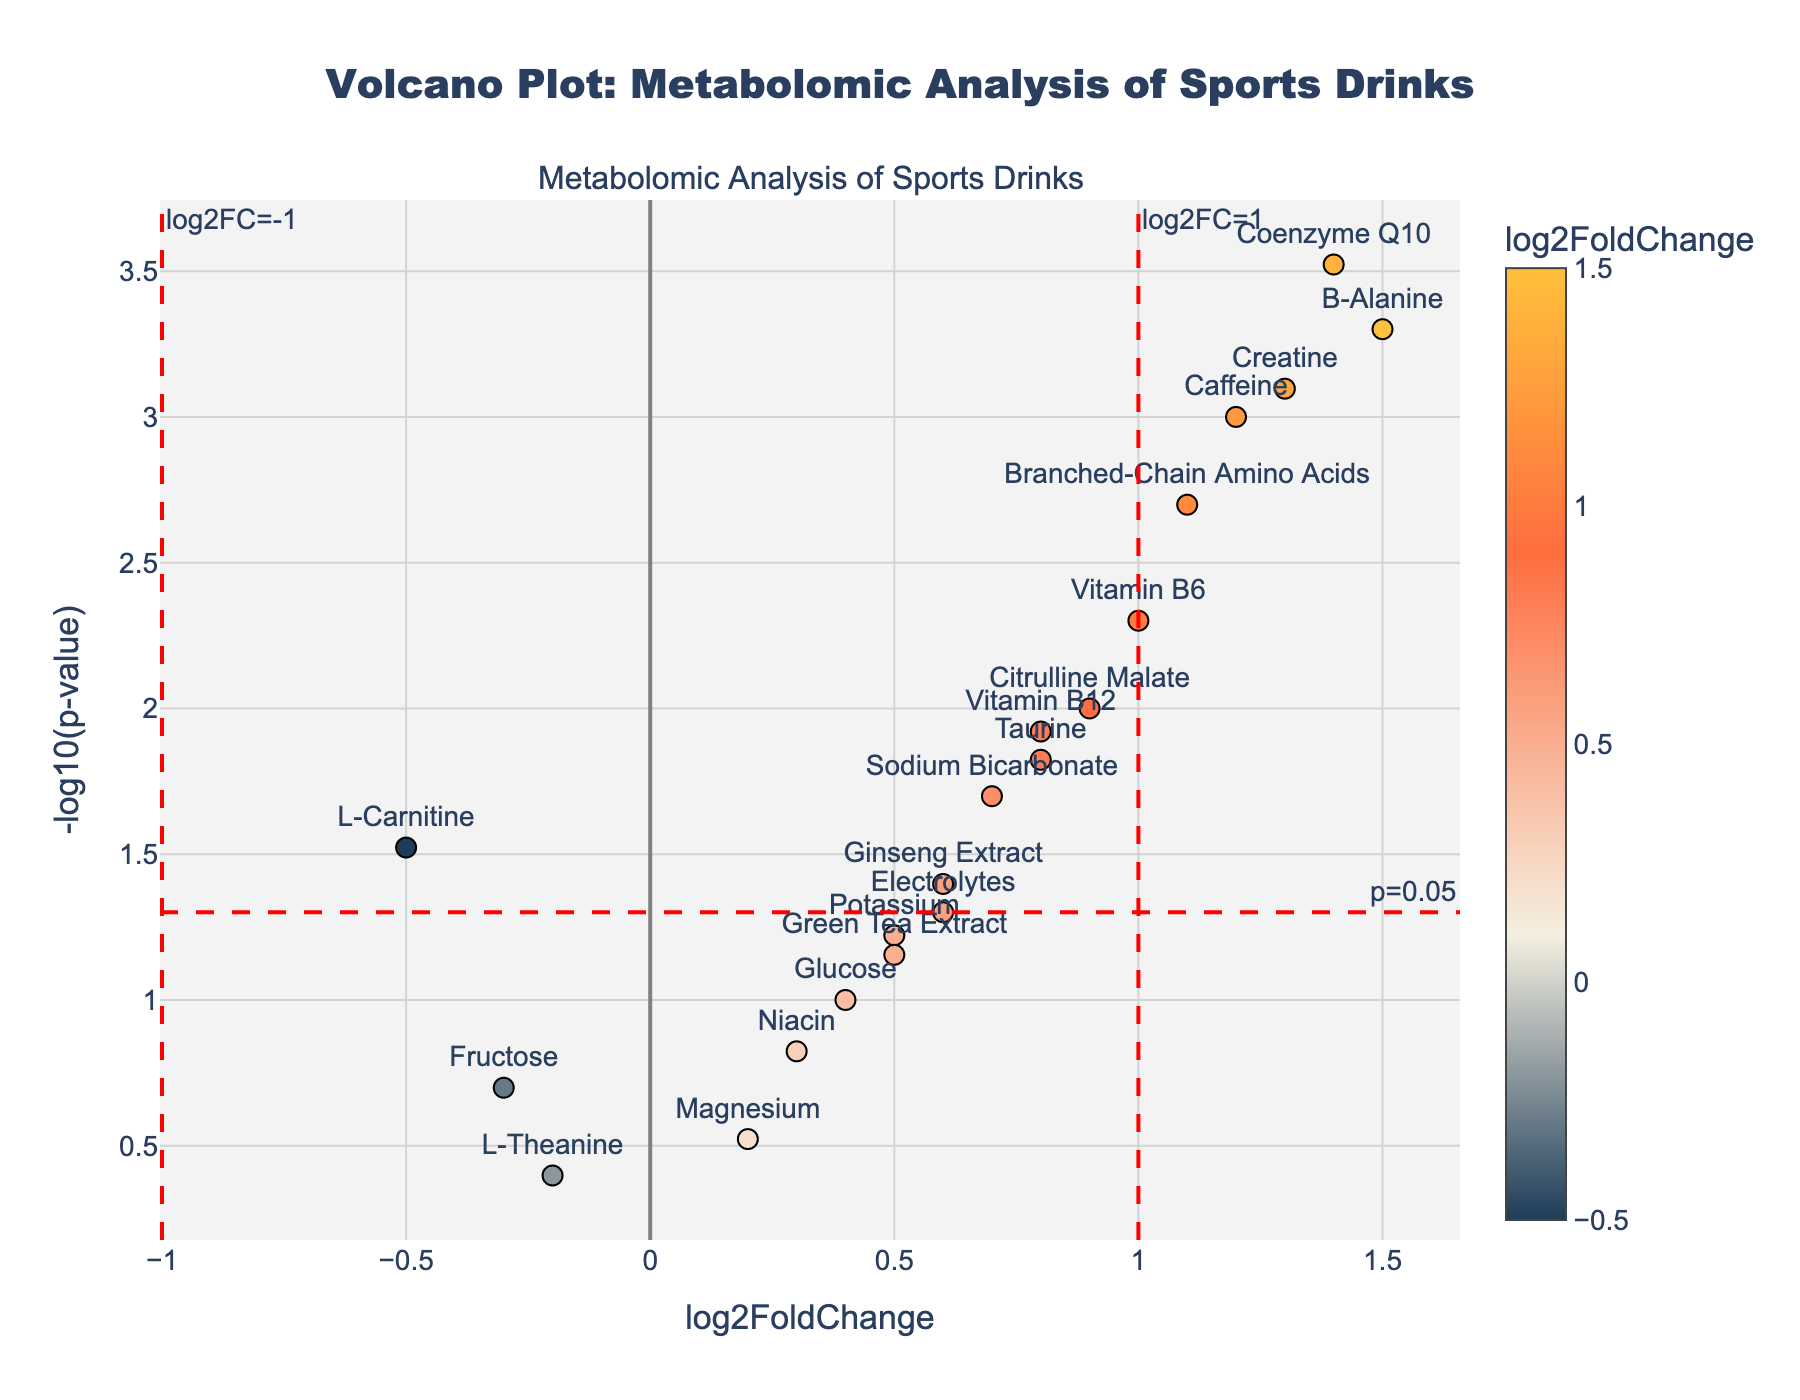What is the title of the volcano plot? The title of the plot is usually found at the top center of the figure. In this case, it is set within the plotting code.
Answer: "Volcano Plot: Metabolomic Analysis of Sports Drinks" What are the x-axis and y-axis labels of the plot? The axis labels are indicated in the code where 'xaxis_title' and 'yaxis_title' are set. The x-axis is "log2FoldChange" and the y-axis is "-log10(p-value)".
Answer: x-axis: "log2FoldChange", y-axis: "-log10(p-value)" How many metabolites have a log2FoldChange greater than 1? Identify the data points where the x-value (log2FoldChange) is greater than 1. From the data, those metabolites are B-Alanine, Creatine, and Coenzyme Q10.
Answer: 3 Which metabolite has the highest -log10(p-value)? The metabolite with the highest -log10(p-value) will be the one at the topmost position on the y-axis. Coenzyme Q10 has the smallest p-value (0.0003), leading to the highest -log10(p-value).
Answer: Coenzyme Q10 What is the log2FoldChange and p-value of Caffeine? Look for the data point labeled "Caffeine" and refer to its hovertext or marker. The log2FoldChange of Caffeine is 1.2, and the p-value is 0.001.
Answer: log2FoldChange: 1.2, p-value: 0.001 Which metabolites are not statistically significant? Statistically insignificant metabolites have p-values greater than 0.05, which corresponds to -log10(p-value) less than 1.3. These are Fructose, Magnesium, L-Theanine, and Green Tea Extract.
Answer: Fructose, Magnesium, L-Theanine, Green Tea Extract Which metabolite has the highest log2FoldChange and what is its corresponding -log10(p-value)? Identify the data point furthest to the right on the x-axis. B-Alanine has the highest log2FoldChange of 1.5. Its p-value is 0.0005, so the -log10(p-value) is log10(0.0005).
Answer: log2FoldChange: 1.5; -log10(p-value): 3.3010 Which metabolite has a negative log2FoldChange but is still statistically significant? A negative log2FoldChange means the point is to the left of 0 on the x-axis; statistically significant means its -log10(p-value) is greater than 1.3. L-Carnitine fits this description.
Answer: L-Carnitine How many metabolites fall within the range of p-value < 0.05 and log2FoldChange > 0? Look at the points above the horizontal threshold line (p-value < 0.05) and to the right of the vertical line (log2FoldChange > 0). These are Caffeine, Taurine, B-Alanine, Citrulline Malate, Branched-Chain Amino Acids, Creatine, Vitamin B6, Vitamin B12, Coenzyme Q10, Sodium Bicarbonate, Ginseng Extract.
Answer: 11 